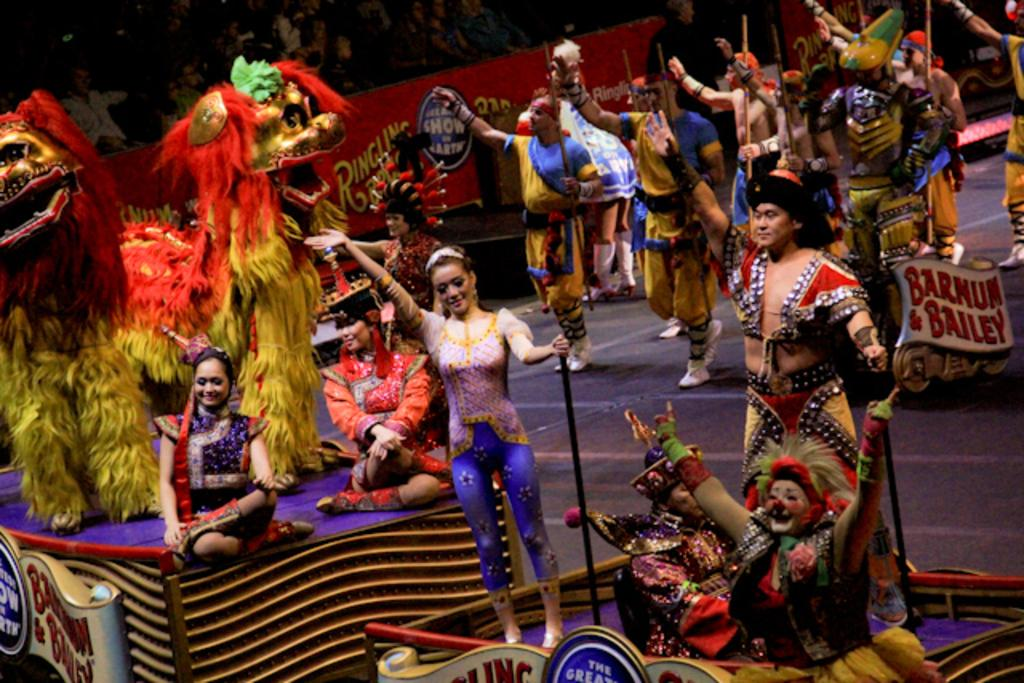What are the people in the image doing? The people in the image are standing and wearing costumes. Are there any other people in the image who are not standing? Yes, there are two persons sitting in the image. What are the sitting persons holding? The sitting persons are holding sticks. What can be seen in the background of the image? There is a hoarding in the image. What type of rail can be seen in the image? There is no rail present in the image. What time of day is it in the image, considering it's an afternoon event? The time of day cannot be determined from the image, and there is no mention of an afternoon event. 